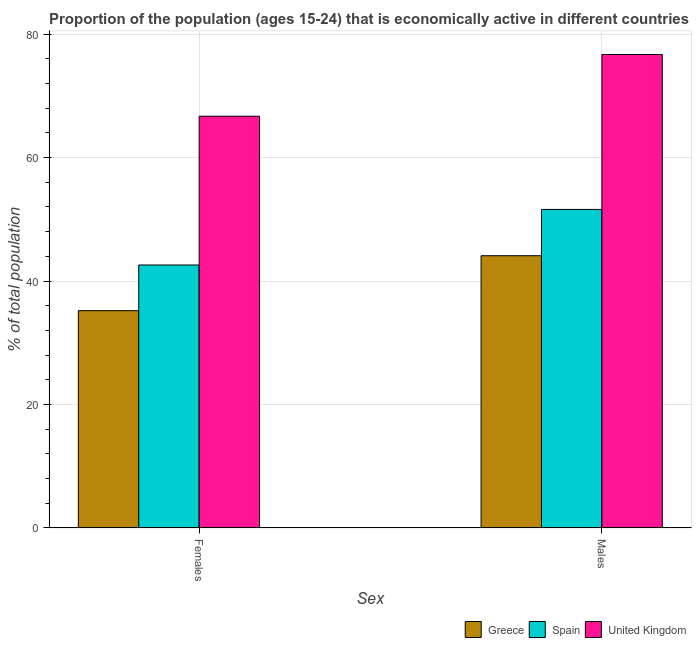How many groups of bars are there?
Give a very brief answer. 2. Are the number of bars on each tick of the X-axis equal?
Give a very brief answer. Yes. How many bars are there on the 2nd tick from the left?
Provide a short and direct response. 3. What is the label of the 2nd group of bars from the left?
Make the answer very short. Males. What is the percentage of economically active female population in Greece?
Offer a terse response. 35.2. Across all countries, what is the maximum percentage of economically active female population?
Keep it short and to the point. 66.7. Across all countries, what is the minimum percentage of economically active female population?
Your response must be concise. 35.2. What is the total percentage of economically active male population in the graph?
Your answer should be very brief. 172.4. What is the difference between the percentage of economically active male population in Spain and that in Greece?
Ensure brevity in your answer.  7.5. What is the difference between the percentage of economically active female population in Greece and the percentage of economically active male population in United Kingdom?
Your response must be concise. -41.5. What is the average percentage of economically active male population per country?
Ensure brevity in your answer.  57.47. What is the difference between the percentage of economically active female population and percentage of economically active male population in Greece?
Ensure brevity in your answer.  -8.9. In how many countries, is the percentage of economically active male population greater than 64 %?
Make the answer very short. 1. What is the ratio of the percentage of economically active female population in United Kingdom to that in Spain?
Make the answer very short. 1.57. How many countries are there in the graph?
Make the answer very short. 3. Are the values on the major ticks of Y-axis written in scientific E-notation?
Your answer should be very brief. No. Does the graph contain any zero values?
Your response must be concise. No. Does the graph contain grids?
Make the answer very short. Yes. Where does the legend appear in the graph?
Your response must be concise. Bottom right. How many legend labels are there?
Make the answer very short. 3. How are the legend labels stacked?
Offer a terse response. Horizontal. What is the title of the graph?
Provide a short and direct response. Proportion of the population (ages 15-24) that is economically active in different countries. What is the label or title of the X-axis?
Keep it short and to the point. Sex. What is the label or title of the Y-axis?
Offer a very short reply. % of total population. What is the % of total population of Greece in Females?
Your answer should be compact. 35.2. What is the % of total population in Spain in Females?
Your answer should be compact. 42.6. What is the % of total population in United Kingdom in Females?
Give a very brief answer. 66.7. What is the % of total population of Greece in Males?
Provide a short and direct response. 44.1. What is the % of total population in Spain in Males?
Provide a short and direct response. 51.6. What is the % of total population of United Kingdom in Males?
Ensure brevity in your answer.  76.7. Across all Sex, what is the maximum % of total population in Greece?
Provide a short and direct response. 44.1. Across all Sex, what is the maximum % of total population in Spain?
Your answer should be compact. 51.6. Across all Sex, what is the maximum % of total population of United Kingdom?
Your response must be concise. 76.7. Across all Sex, what is the minimum % of total population of Greece?
Your response must be concise. 35.2. Across all Sex, what is the minimum % of total population in Spain?
Make the answer very short. 42.6. Across all Sex, what is the minimum % of total population of United Kingdom?
Your response must be concise. 66.7. What is the total % of total population of Greece in the graph?
Provide a short and direct response. 79.3. What is the total % of total population of Spain in the graph?
Your answer should be very brief. 94.2. What is the total % of total population in United Kingdom in the graph?
Your answer should be compact. 143.4. What is the difference between the % of total population in Greece in Females and that in Males?
Give a very brief answer. -8.9. What is the difference between the % of total population of United Kingdom in Females and that in Males?
Your answer should be compact. -10. What is the difference between the % of total population of Greece in Females and the % of total population of Spain in Males?
Offer a terse response. -16.4. What is the difference between the % of total population in Greece in Females and the % of total population in United Kingdom in Males?
Give a very brief answer. -41.5. What is the difference between the % of total population of Spain in Females and the % of total population of United Kingdom in Males?
Make the answer very short. -34.1. What is the average % of total population in Greece per Sex?
Keep it short and to the point. 39.65. What is the average % of total population in Spain per Sex?
Provide a succinct answer. 47.1. What is the average % of total population in United Kingdom per Sex?
Make the answer very short. 71.7. What is the difference between the % of total population in Greece and % of total population in United Kingdom in Females?
Ensure brevity in your answer.  -31.5. What is the difference between the % of total population in Spain and % of total population in United Kingdom in Females?
Your answer should be compact. -24.1. What is the difference between the % of total population in Greece and % of total population in United Kingdom in Males?
Give a very brief answer. -32.6. What is the difference between the % of total population of Spain and % of total population of United Kingdom in Males?
Offer a terse response. -25.1. What is the ratio of the % of total population of Greece in Females to that in Males?
Provide a succinct answer. 0.8. What is the ratio of the % of total population in Spain in Females to that in Males?
Give a very brief answer. 0.83. What is the ratio of the % of total population in United Kingdom in Females to that in Males?
Provide a succinct answer. 0.87. What is the difference between the highest and the second highest % of total population of Spain?
Ensure brevity in your answer.  9. What is the difference between the highest and the lowest % of total population of United Kingdom?
Provide a short and direct response. 10. 